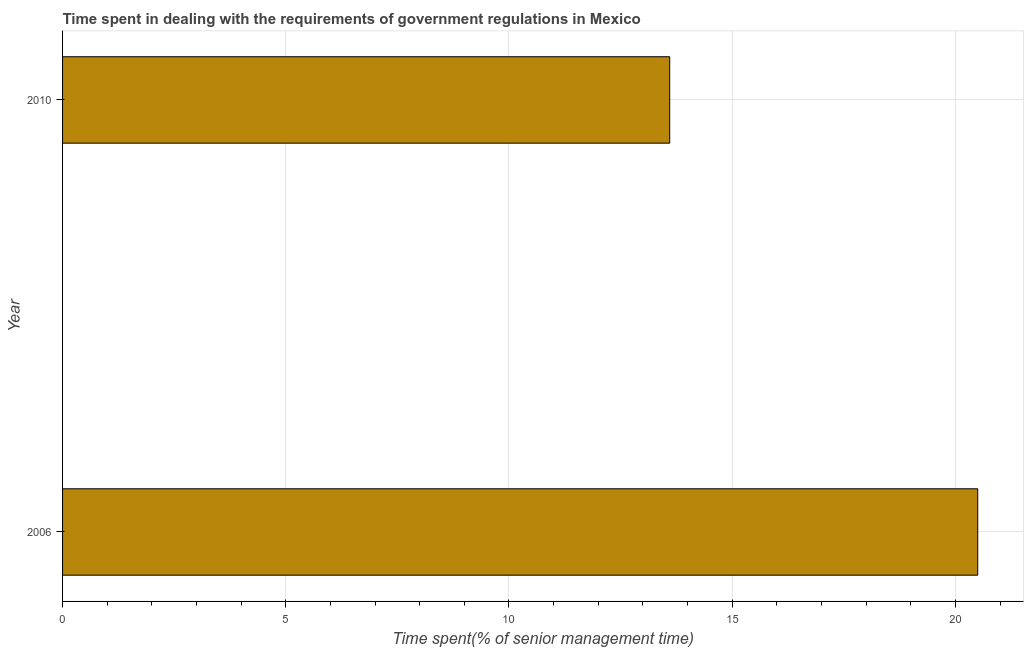What is the title of the graph?
Ensure brevity in your answer.  Time spent in dealing with the requirements of government regulations in Mexico. What is the label or title of the X-axis?
Your response must be concise. Time spent(% of senior management time). Across all years, what is the maximum time spent in dealing with government regulations?
Give a very brief answer. 20.5. Across all years, what is the minimum time spent in dealing with government regulations?
Give a very brief answer. 13.6. In which year was the time spent in dealing with government regulations maximum?
Provide a short and direct response. 2006. What is the sum of the time spent in dealing with government regulations?
Your answer should be compact. 34.1. What is the average time spent in dealing with government regulations per year?
Give a very brief answer. 17.05. What is the median time spent in dealing with government regulations?
Ensure brevity in your answer.  17.05. In how many years, is the time spent in dealing with government regulations greater than 4 %?
Provide a succinct answer. 2. Do a majority of the years between 2006 and 2010 (inclusive) have time spent in dealing with government regulations greater than 7 %?
Provide a short and direct response. Yes. What is the ratio of the time spent in dealing with government regulations in 2006 to that in 2010?
Provide a short and direct response. 1.51. Is the time spent in dealing with government regulations in 2006 less than that in 2010?
Your response must be concise. No. How many bars are there?
Offer a terse response. 2. Are all the bars in the graph horizontal?
Ensure brevity in your answer.  Yes. What is the difference between two consecutive major ticks on the X-axis?
Your answer should be very brief. 5. What is the Time spent(% of senior management time) of 2006?
Give a very brief answer. 20.5. What is the ratio of the Time spent(% of senior management time) in 2006 to that in 2010?
Ensure brevity in your answer.  1.51. 